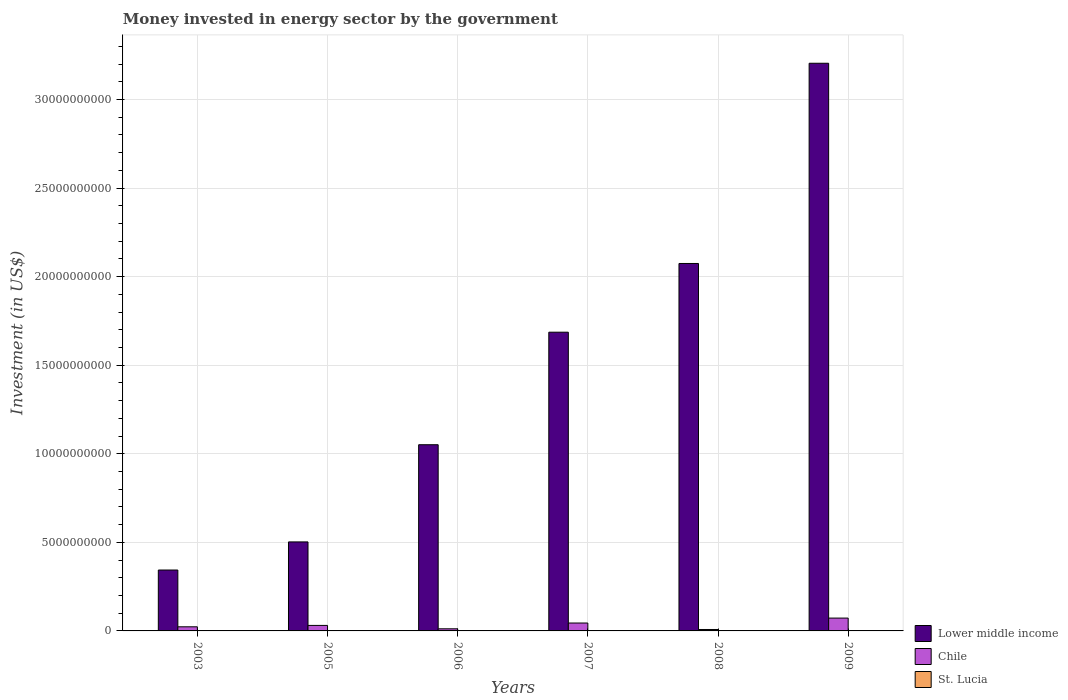How many different coloured bars are there?
Your answer should be very brief. 3. Are the number of bars on each tick of the X-axis equal?
Make the answer very short. Yes. In how many cases, is the number of bars for a given year not equal to the number of legend labels?
Your answer should be very brief. 0. What is the money spent in energy sector in Lower middle income in 2007?
Ensure brevity in your answer.  1.69e+1. Across all years, what is the maximum money spent in energy sector in Chile?
Offer a very short reply. 7.25e+08. Across all years, what is the minimum money spent in energy sector in Lower middle income?
Your answer should be compact. 3.44e+09. In which year was the money spent in energy sector in Chile minimum?
Ensure brevity in your answer.  2008. What is the total money spent in energy sector in Lower middle income in the graph?
Provide a succinct answer. 8.86e+1. What is the difference between the money spent in energy sector in St. Lucia in 2007 and that in 2009?
Give a very brief answer. 7.80e+06. What is the difference between the money spent in energy sector in Lower middle income in 2007 and the money spent in energy sector in St. Lucia in 2009?
Make the answer very short. 1.69e+1. What is the average money spent in energy sector in Lower middle income per year?
Ensure brevity in your answer.  1.48e+1. In the year 2003, what is the difference between the money spent in energy sector in Lower middle income and money spent in energy sector in Chile?
Make the answer very short. 3.21e+09. In how many years, is the money spent in energy sector in Lower middle income greater than 29000000000 US$?
Your response must be concise. 1. What is the ratio of the money spent in energy sector in St. Lucia in 2007 to that in 2008?
Your answer should be very brief. 1.81. Is the difference between the money spent in energy sector in Lower middle income in 2006 and 2008 greater than the difference between the money spent in energy sector in Chile in 2006 and 2008?
Provide a short and direct response. No. What is the difference between the highest and the second highest money spent in energy sector in Chile?
Your response must be concise. 2.79e+08. What is the difference between the highest and the lowest money spent in energy sector in St. Lucia?
Make the answer very short. 1.26e+07. In how many years, is the money spent in energy sector in Chile greater than the average money spent in energy sector in Chile taken over all years?
Provide a short and direct response. 2. What does the 3rd bar from the left in 2006 represents?
Ensure brevity in your answer.  St. Lucia. What does the 3rd bar from the right in 2005 represents?
Your response must be concise. Lower middle income. How many years are there in the graph?
Keep it short and to the point. 6. What is the difference between two consecutive major ticks on the Y-axis?
Your answer should be compact. 5.00e+09. Are the values on the major ticks of Y-axis written in scientific E-notation?
Make the answer very short. No. What is the title of the graph?
Your answer should be very brief. Money invested in energy sector by the government. Does "Seychelles" appear as one of the legend labels in the graph?
Ensure brevity in your answer.  No. What is the label or title of the Y-axis?
Offer a terse response. Investment (in US$). What is the Investment (in US$) of Lower middle income in 2003?
Ensure brevity in your answer.  3.44e+09. What is the Investment (in US$) in Chile in 2003?
Make the answer very short. 2.33e+08. What is the Investment (in US$) in St. Lucia in 2003?
Keep it short and to the point. 6.40e+06. What is the Investment (in US$) of Lower middle income in 2005?
Provide a short and direct response. 5.03e+09. What is the Investment (in US$) of Chile in 2005?
Make the answer very short. 3.11e+08. What is the Investment (in US$) of Lower middle income in 2006?
Your answer should be compact. 1.05e+1. What is the Investment (in US$) of Chile in 2006?
Ensure brevity in your answer.  1.19e+08. What is the Investment (in US$) of St. Lucia in 2006?
Keep it short and to the point. 9.70e+06. What is the Investment (in US$) in Lower middle income in 2007?
Ensure brevity in your answer.  1.69e+1. What is the Investment (in US$) in Chile in 2007?
Ensure brevity in your answer.  4.46e+08. What is the Investment (in US$) in St. Lucia in 2007?
Offer a terse response. 1.90e+07. What is the Investment (in US$) in Lower middle income in 2008?
Give a very brief answer. 2.07e+1. What is the Investment (in US$) of Chile in 2008?
Give a very brief answer. 8.09e+07. What is the Investment (in US$) of St. Lucia in 2008?
Offer a very short reply. 1.05e+07. What is the Investment (in US$) in Lower middle income in 2009?
Offer a very short reply. 3.20e+1. What is the Investment (in US$) in Chile in 2009?
Keep it short and to the point. 7.25e+08. What is the Investment (in US$) of St. Lucia in 2009?
Offer a terse response. 1.12e+07. Across all years, what is the maximum Investment (in US$) of Lower middle income?
Your response must be concise. 3.20e+1. Across all years, what is the maximum Investment (in US$) in Chile?
Provide a short and direct response. 7.25e+08. Across all years, what is the maximum Investment (in US$) of St. Lucia?
Make the answer very short. 1.90e+07. Across all years, what is the minimum Investment (in US$) of Lower middle income?
Offer a very short reply. 3.44e+09. Across all years, what is the minimum Investment (in US$) in Chile?
Give a very brief answer. 8.09e+07. Across all years, what is the minimum Investment (in US$) in St. Lucia?
Ensure brevity in your answer.  6.40e+06. What is the total Investment (in US$) of Lower middle income in the graph?
Give a very brief answer. 8.86e+1. What is the total Investment (in US$) in Chile in the graph?
Your answer should be very brief. 1.92e+09. What is the total Investment (in US$) in St. Lucia in the graph?
Offer a very short reply. 6.68e+07. What is the difference between the Investment (in US$) in Lower middle income in 2003 and that in 2005?
Offer a terse response. -1.59e+09. What is the difference between the Investment (in US$) of Chile in 2003 and that in 2005?
Your answer should be very brief. -7.82e+07. What is the difference between the Investment (in US$) in St. Lucia in 2003 and that in 2005?
Your answer should be very brief. -3.60e+06. What is the difference between the Investment (in US$) of Lower middle income in 2003 and that in 2006?
Your response must be concise. -7.07e+09. What is the difference between the Investment (in US$) of Chile in 2003 and that in 2006?
Ensure brevity in your answer.  1.14e+08. What is the difference between the Investment (in US$) in St. Lucia in 2003 and that in 2006?
Keep it short and to the point. -3.30e+06. What is the difference between the Investment (in US$) of Lower middle income in 2003 and that in 2007?
Keep it short and to the point. -1.34e+1. What is the difference between the Investment (in US$) of Chile in 2003 and that in 2007?
Keep it short and to the point. -2.13e+08. What is the difference between the Investment (in US$) in St. Lucia in 2003 and that in 2007?
Ensure brevity in your answer.  -1.26e+07. What is the difference between the Investment (in US$) of Lower middle income in 2003 and that in 2008?
Your response must be concise. -1.73e+1. What is the difference between the Investment (in US$) of Chile in 2003 and that in 2008?
Your answer should be compact. 1.52e+08. What is the difference between the Investment (in US$) of St. Lucia in 2003 and that in 2008?
Offer a very short reply. -4.10e+06. What is the difference between the Investment (in US$) in Lower middle income in 2003 and that in 2009?
Make the answer very short. -2.86e+1. What is the difference between the Investment (in US$) in Chile in 2003 and that in 2009?
Offer a very short reply. -4.92e+08. What is the difference between the Investment (in US$) of St. Lucia in 2003 and that in 2009?
Offer a terse response. -4.80e+06. What is the difference between the Investment (in US$) in Lower middle income in 2005 and that in 2006?
Offer a terse response. -5.49e+09. What is the difference between the Investment (in US$) of Chile in 2005 and that in 2006?
Provide a succinct answer. 1.92e+08. What is the difference between the Investment (in US$) in Lower middle income in 2005 and that in 2007?
Your answer should be very brief. -1.18e+1. What is the difference between the Investment (in US$) in Chile in 2005 and that in 2007?
Give a very brief answer. -1.35e+08. What is the difference between the Investment (in US$) of St. Lucia in 2005 and that in 2007?
Your response must be concise. -9.00e+06. What is the difference between the Investment (in US$) in Lower middle income in 2005 and that in 2008?
Keep it short and to the point. -1.57e+1. What is the difference between the Investment (in US$) in Chile in 2005 and that in 2008?
Provide a succinct answer. 2.30e+08. What is the difference between the Investment (in US$) in St. Lucia in 2005 and that in 2008?
Ensure brevity in your answer.  -5.00e+05. What is the difference between the Investment (in US$) of Lower middle income in 2005 and that in 2009?
Give a very brief answer. -2.70e+1. What is the difference between the Investment (in US$) of Chile in 2005 and that in 2009?
Provide a succinct answer. -4.14e+08. What is the difference between the Investment (in US$) in St. Lucia in 2005 and that in 2009?
Your answer should be very brief. -1.20e+06. What is the difference between the Investment (in US$) in Lower middle income in 2006 and that in 2007?
Make the answer very short. -6.35e+09. What is the difference between the Investment (in US$) of Chile in 2006 and that in 2007?
Your response must be concise. -3.27e+08. What is the difference between the Investment (in US$) in St. Lucia in 2006 and that in 2007?
Offer a terse response. -9.30e+06. What is the difference between the Investment (in US$) of Lower middle income in 2006 and that in 2008?
Give a very brief answer. -1.02e+1. What is the difference between the Investment (in US$) of Chile in 2006 and that in 2008?
Offer a very short reply. 3.84e+07. What is the difference between the Investment (in US$) of St. Lucia in 2006 and that in 2008?
Your answer should be very brief. -8.00e+05. What is the difference between the Investment (in US$) in Lower middle income in 2006 and that in 2009?
Give a very brief answer. -2.15e+1. What is the difference between the Investment (in US$) of Chile in 2006 and that in 2009?
Provide a succinct answer. -6.06e+08. What is the difference between the Investment (in US$) of St. Lucia in 2006 and that in 2009?
Ensure brevity in your answer.  -1.50e+06. What is the difference between the Investment (in US$) in Lower middle income in 2007 and that in 2008?
Provide a succinct answer. -3.88e+09. What is the difference between the Investment (in US$) of Chile in 2007 and that in 2008?
Offer a very short reply. 3.65e+08. What is the difference between the Investment (in US$) in St. Lucia in 2007 and that in 2008?
Offer a terse response. 8.50e+06. What is the difference between the Investment (in US$) of Lower middle income in 2007 and that in 2009?
Keep it short and to the point. -1.52e+1. What is the difference between the Investment (in US$) of Chile in 2007 and that in 2009?
Ensure brevity in your answer.  -2.79e+08. What is the difference between the Investment (in US$) of St. Lucia in 2007 and that in 2009?
Provide a succinct answer. 7.80e+06. What is the difference between the Investment (in US$) of Lower middle income in 2008 and that in 2009?
Offer a terse response. -1.13e+1. What is the difference between the Investment (in US$) of Chile in 2008 and that in 2009?
Offer a very short reply. -6.44e+08. What is the difference between the Investment (in US$) of St. Lucia in 2008 and that in 2009?
Your answer should be very brief. -7.00e+05. What is the difference between the Investment (in US$) of Lower middle income in 2003 and the Investment (in US$) of Chile in 2005?
Make the answer very short. 3.13e+09. What is the difference between the Investment (in US$) of Lower middle income in 2003 and the Investment (in US$) of St. Lucia in 2005?
Provide a succinct answer. 3.43e+09. What is the difference between the Investment (in US$) of Chile in 2003 and the Investment (in US$) of St. Lucia in 2005?
Give a very brief answer. 2.23e+08. What is the difference between the Investment (in US$) of Lower middle income in 2003 and the Investment (in US$) of Chile in 2006?
Make the answer very short. 3.32e+09. What is the difference between the Investment (in US$) of Lower middle income in 2003 and the Investment (in US$) of St. Lucia in 2006?
Provide a succinct answer. 3.43e+09. What is the difference between the Investment (in US$) of Chile in 2003 and the Investment (in US$) of St. Lucia in 2006?
Make the answer very short. 2.23e+08. What is the difference between the Investment (in US$) of Lower middle income in 2003 and the Investment (in US$) of Chile in 2007?
Make the answer very short. 2.99e+09. What is the difference between the Investment (in US$) of Lower middle income in 2003 and the Investment (in US$) of St. Lucia in 2007?
Your response must be concise. 3.42e+09. What is the difference between the Investment (in US$) in Chile in 2003 and the Investment (in US$) in St. Lucia in 2007?
Provide a succinct answer. 2.14e+08. What is the difference between the Investment (in US$) of Lower middle income in 2003 and the Investment (in US$) of Chile in 2008?
Your answer should be very brief. 3.36e+09. What is the difference between the Investment (in US$) of Lower middle income in 2003 and the Investment (in US$) of St. Lucia in 2008?
Provide a short and direct response. 3.43e+09. What is the difference between the Investment (in US$) of Chile in 2003 and the Investment (in US$) of St. Lucia in 2008?
Your answer should be compact. 2.22e+08. What is the difference between the Investment (in US$) in Lower middle income in 2003 and the Investment (in US$) in Chile in 2009?
Provide a succinct answer. 2.71e+09. What is the difference between the Investment (in US$) of Lower middle income in 2003 and the Investment (in US$) of St. Lucia in 2009?
Give a very brief answer. 3.43e+09. What is the difference between the Investment (in US$) in Chile in 2003 and the Investment (in US$) in St. Lucia in 2009?
Your response must be concise. 2.22e+08. What is the difference between the Investment (in US$) of Lower middle income in 2005 and the Investment (in US$) of Chile in 2006?
Ensure brevity in your answer.  4.91e+09. What is the difference between the Investment (in US$) of Lower middle income in 2005 and the Investment (in US$) of St. Lucia in 2006?
Your answer should be compact. 5.02e+09. What is the difference between the Investment (in US$) in Chile in 2005 and the Investment (in US$) in St. Lucia in 2006?
Provide a succinct answer. 3.01e+08. What is the difference between the Investment (in US$) in Lower middle income in 2005 and the Investment (in US$) in Chile in 2007?
Keep it short and to the point. 4.58e+09. What is the difference between the Investment (in US$) of Lower middle income in 2005 and the Investment (in US$) of St. Lucia in 2007?
Make the answer very short. 5.01e+09. What is the difference between the Investment (in US$) in Chile in 2005 and the Investment (in US$) in St. Lucia in 2007?
Your answer should be very brief. 2.92e+08. What is the difference between the Investment (in US$) in Lower middle income in 2005 and the Investment (in US$) in Chile in 2008?
Offer a terse response. 4.94e+09. What is the difference between the Investment (in US$) of Lower middle income in 2005 and the Investment (in US$) of St. Lucia in 2008?
Ensure brevity in your answer.  5.02e+09. What is the difference between the Investment (in US$) of Chile in 2005 and the Investment (in US$) of St. Lucia in 2008?
Offer a very short reply. 3.00e+08. What is the difference between the Investment (in US$) of Lower middle income in 2005 and the Investment (in US$) of Chile in 2009?
Provide a succinct answer. 4.30e+09. What is the difference between the Investment (in US$) in Lower middle income in 2005 and the Investment (in US$) in St. Lucia in 2009?
Offer a very short reply. 5.01e+09. What is the difference between the Investment (in US$) of Chile in 2005 and the Investment (in US$) of St. Lucia in 2009?
Give a very brief answer. 3.00e+08. What is the difference between the Investment (in US$) of Lower middle income in 2006 and the Investment (in US$) of Chile in 2007?
Ensure brevity in your answer.  1.01e+1. What is the difference between the Investment (in US$) in Lower middle income in 2006 and the Investment (in US$) in St. Lucia in 2007?
Your answer should be very brief. 1.05e+1. What is the difference between the Investment (in US$) of Chile in 2006 and the Investment (in US$) of St. Lucia in 2007?
Offer a terse response. 1.00e+08. What is the difference between the Investment (in US$) of Lower middle income in 2006 and the Investment (in US$) of Chile in 2008?
Provide a short and direct response. 1.04e+1. What is the difference between the Investment (in US$) in Lower middle income in 2006 and the Investment (in US$) in St. Lucia in 2008?
Your answer should be very brief. 1.05e+1. What is the difference between the Investment (in US$) of Chile in 2006 and the Investment (in US$) of St. Lucia in 2008?
Provide a short and direct response. 1.09e+08. What is the difference between the Investment (in US$) in Lower middle income in 2006 and the Investment (in US$) in Chile in 2009?
Offer a very short reply. 9.79e+09. What is the difference between the Investment (in US$) in Lower middle income in 2006 and the Investment (in US$) in St. Lucia in 2009?
Provide a short and direct response. 1.05e+1. What is the difference between the Investment (in US$) of Chile in 2006 and the Investment (in US$) of St. Lucia in 2009?
Give a very brief answer. 1.08e+08. What is the difference between the Investment (in US$) of Lower middle income in 2007 and the Investment (in US$) of Chile in 2008?
Offer a terse response. 1.68e+1. What is the difference between the Investment (in US$) of Lower middle income in 2007 and the Investment (in US$) of St. Lucia in 2008?
Keep it short and to the point. 1.69e+1. What is the difference between the Investment (in US$) of Chile in 2007 and the Investment (in US$) of St. Lucia in 2008?
Provide a short and direct response. 4.35e+08. What is the difference between the Investment (in US$) in Lower middle income in 2007 and the Investment (in US$) in Chile in 2009?
Ensure brevity in your answer.  1.61e+1. What is the difference between the Investment (in US$) in Lower middle income in 2007 and the Investment (in US$) in St. Lucia in 2009?
Your response must be concise. 1.69e+1. What is the difference between the Investment (in US$) of Chile in 2007 and the Investment (in US$) of St. Lucia in 2009?
Your response must be concise. 4.35e+08. What is the difference between the Investment (in US$) in Lower middle income in 2008 and the Investment (in US$) in Chile in 2009?
Your answer should be very brief. 2.00e+1. What is the difference between the Investment (in US$) of Lower middle income in 2008 and the Investment (in US$) of St. Lucia in 2009?
Your answer should be very brief. 2.07e+1. What is the difference between the Investment (in US$) in Chile in 2008 and the Investment (in US$) in St. Lucia in 2009?
Offer a terse response. 6.97e+07. What is the average Investment (in US$) in Lower middle income per year?
Provide a short and direct response. 1.48e+1. What is the average Investment (in US$) in Chile per year?
Your response must be concise. 3.19e+08. What is the average Investment (in US$) in St. Lucia per year?
Offer a very short reply. 1.11e+07. In the year 2003, what is the difference between the Investment (in US$) of Lower middle income and Investment (in US$) of Chile?
Offer a very short reply. 3.21e+09. In the year 2003, what is the difference between the Investment (in US$) in Lower middle income and Investment (in US$) in St. Lucia?
Offer a very short reply. 3.43e+09. In the year 2003, what is the difference between the Investment (in US$) in Chile and Investment (in US$) in St. Lucia?
Provide a short and direct response. 2.26e+08. In the year 2005, what is the difference between the Investment (in US$) in Lower middle income and Investment (in US$) in Chile?
Provide a short and direct response. 4.71e+09. In the year 2005, what is the difference between the Investment (in US$) of Lower middle income and Investment (in US$) of St. Lucia?
Give a very brief answer. 5.02e+09. In the year 2005, what is the difference between the Investment (in US$) of Chile and Investment (in US$) of St. Lucia?
Your answer should be compact. 3.01e+08. In the year 2006, what is the difference between the Investment (in US$) of Lower middle income and Investment (in US$) of Chile?
Provide a short and direct response. 1.04e+1. In the year 2006, what is the difference between the Investment (in US$) of Lower middle income and Investment (in US$) of St. Lucia?
Ensure brevity in your answer.  1.05e+1. In the year 2006, what is the difference between the Investment (in US$) in Chile and Investment (in US$) in St. Lucia?
Your response must be concise. 1.10e+08. In the year 2007, what is the difference between the Investment (in US$) in Lower middle income and Investment (in US$) in Chile?
Your answer should be compact. 1.64e+1. In the year 2007, what is the difference between the Investment (in US$) of Lower middle income and Investment (in US$) of St. Lucia?
Your answer should be compact. 1.68e+1. In the year 2007, what is the difference between the Investment (in US$) of Chile and Investment (in US$) of St. Lucia?
Give a very brief answer. 4.27e+08. In the year 2008, what is the difference between the Investment (in US$) of Lower middle income and Investment (in US$) of Chile?
Make the answer very short. 2.07e+1. In the year 2008, what is the difference between the Investment (in US$) in Lower middle income and Investment (in US$) in St. Lucia?
Ensure brevity in your answer.  2.07e+1. In the year 2008, what is the difference between the Investment (in US$) of Chile and Investment (in US$) of St. Lucia?
Offer a very short reply. 7.04e+07. In the year 2009, what is the difference between the Investment (in US$) of Lower middle income and Investment (in US$) of Chile?
Provide a succinct answer. 3.13e+1. In the year 2009, what is the difference between the Investment (in US$) of Lower middle income and Investment (in US$) of St. Lucia?
Make the answer very short. 3.20e+1. In the year 2009, what is the difference between the Investment (in US$) in Chile and Investment (in US$) in St. Lucia?
Ensure brevity in your answer.  7.14e+08. What is the ratio of the Investment (in US$) of Lower middle income in 2003 to that in 2005?
Make the answer very short. 0.68. What is the ratio of the Investment (in US$) in Chile in 2003 to that in 2005?
Provide a short and direct response. 0.75. What is the ratio of the Investment (in US$) in St. Lucia in 2003 to that in 2005?
Give a very brief answer. 0.64. What is the ratio of the Investment (in US$) in Lower middle income in 2003 to that in 2006?
Offer a terse response. 0.33. What is the ratio of the Investment (in US$) in Chile in 2003 to that in 2006?
Your answer should be very brief. 1.95. What is the ratio of the Investment (in US$) in St. Lucia in 2003 to that in 2006?
Provide a succinct answer. 0.66. What is the ratio of the Investment (in US$) of Lower middle income in 2003 to that in 2007?
Provide a short and direct response. 0.2. What is the ratio of the Investment (in US$) in Chile in 2003 to that in 2007?
Keep it short and to the point. 0.52. What is the ratio of the Investment (in US$) of St. Lucia in 2003 to that in 2007?
Provide a succinct answer. 0.34. What is the ratio of the Investment (in US$) in Lower middle income in 2003 to that in 2008?
Your response must be concise. 0.17. What is the ratio of the Investment (in US$) in Chile in 2003 to that in 2008?
Your answer should be very brief. 2.88. What is the ratio of the Investment (in US$) of St. Lucia in 2003 to that in 2008?
Give a very brief answer. 0.61. What is the ratio of the Investment (in US$) in Lower middle income in 2003 to that in 2009?
Your answer should be very brief. 0.11. What is the ratio of the Investment (in US$) in Chile in 2003 to that in 2009?
Your answer should be compact. 0.32. What is the ratio of the Investment (in US$) in St. Lucia in 2003 to that in 2009?
Your response must be concise. 0.57. What is the ratio of the Investment (in US$) of Lower middle income in 2005 to that in 2006?
Your answer should be compact. 0.48. What is the ratio of the Investment (in US$) of Chile in 2005 to that in 2006?
Your answer should be compact. 2.61. What is the ratio of the Investment (in US$) of St. Lucia in 2005 to that in 2006?
Offer a terse response. 1.03. What is the ratio of the Investment (in US$) of Lower middle income in 2005 to that in 2007?
Offer a terse response. 0.3. What is the ratio of the Investment (in US$) in Chile in 2005 to that in 2007?
Provide a short and direct response. 0.7. What is the ratio of the Investment (in US$) of St. Lucia in 2005 to that in 2007?
Your answer should be compact. 0.53. What is the ratio of the Investment (in US$) in Lower middle income in 2005 to that in 2008?
Keep it short and to the point. 0.24. What is the ratio of the Investment (in US$) of Chile in 2005 to that in 2008?
Give a very brief answer. 3.85. What is the ratio of the Investment (in US$) of Lower middle income in 2005 to that in 2009?
Offer a terse response. 0.16. What is the ratio of the Investment (in US$) in Chile in 2005 to that in 2009?
Offer a very short reply. 0.43. What is the ratio of the Investment (in US$) of St. Lucia in 2005 to that in 2009?
Your response must be concise. 0.89. What is the ratio of the Investment (in US$) of Lower middle income in 2006 to that in 2007?
Provide a succinct answer. 0.62. What is the ratio of the Investment (in US$) of Chile in 2006 to that in 2007?
Your response must be concise. 0.27. What is the ratio of the Investment (in US$) of St. Lucia in 2006 to that in 2007?
Offer a terse response. 0.51. What is the ratio of the Investment (in US$) of Lower middle income in 2006 to that in 2008?
Offer a very short reply. 0.51. What is the ratio of the Investment (in US$) of Chile in 2006 to that in 2008?
Offer a terse response. 1.48. What is the ratio of the Investment (in US$) in St. Lucia in 2006 to that in 2008?
Ensure brevity in your answer.  0.92. What is the ratio of the Investment (in US$) of Lower middle income in 2006 to that in 2009?
Keep it short and to the point. 0.33. What is the ratio of the Investment (in US$) in Chile in 2006 to that in 2009?
Provide a short and direct response. 0.16. What is the ratio of the Investment (in US$) of St. Lucia in 2006 to that in 2009?
Ensure brevity in your answer.  0.87. What is the ratio of the Investment (in US$) of Lower middle income in 2007 to that in 2008?
Give a very brief answer. 0.81. What is the ratio of the Investment (in US$) of Chile in 2007 to that in 2008?
Provide a succinct answer. 5.51. What is the ratio of the Investment (in US$) in St. Lucia in 2007 to that in 2008?
Your response must be concise. 1.81. What is the ratio of the Investment (in US$) of Lower middle income in 2007 to that in 2009?
Make the answer very short. 0.53. What is the ratio of the Investment (in US$) of Chile in 2007 to that in 2009?
Offer a terse response. 0.61. What is the ratio of the Investment (in US$) of St. Lucia in 2007 to that in 2009?
Offer a very short reply. 1.7. What is the ratio of the Investment (in US$) in Lower middle income in 2008 to that in 2009?
Give a very brief answer. 0.65. What is the ratio of the Investment (in US$) in Chile in 2008 to that in 2009?
Ensure brevity in your answer.  0.11. What is the ratio of the Investment (in US$) in St. Lucia in 2008 to that in 2009?
Your response must be concise. 0.94. What is the difference between the highest and the second highest Investment (in US$) of Lower middle income?
Ensure brevity in your answer.  1.13e+1. What is the difference between the highest and the second highest Investment (in US$) of Chile?
Provide a succinct answer. 2.79e+08. What is the difference between the highest and the second highest Investment (in US$) in St. Lucia?
Give a very brief answer. 7.80e+06. What is the difference between the highest and the lowest Investment (in US$) in Lower middle income?
Offer a terse response. 2.86e+1. What is the difference between the highest and the lowest Investment (in US$) in Chile?
Provide a succinct answer. 6.44e+08. What is the difference between the highest and the lowest Investment (in US$) in St. Lucia?
Give a very brief answer. 1.26e+07. 